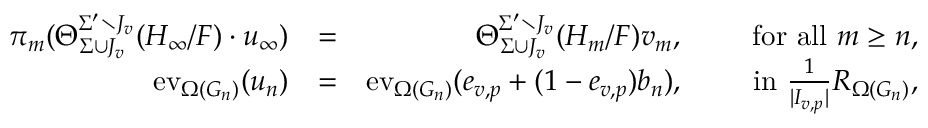<formula> <loc_0><loc_0><loc_500><loc_500>\begin{array} { r l r } { \pi _ { m } ( \Theta _ { \Sigma \cup J _ { v } } ^ { \Sigma ^ { \prime } \ J _ { v } } ( H _ { \infty } / F ) \cdot u _ { \infty } ) } & { = } & { \Theta _ { \Sigma \cup J _ { v } } ^ { \Sigma ^ { \prime } \ J _ { v } } ( H _ { m } / F ) v _ { m } , \quad f o r a l l m \geq n , } \\ { e v _ { \Omega ( G _ { n } ) } ( u _ { n } ) } & { = } & { e v _ { \Omega ( G _ { n } ) } ( e _ { v , p } + ( 1 - e _ { v , p } ) b _ { n } ) , \quad i n \frac { 1 } { | I _ { v , p } | } R _ { \Omega ( G _ { n } ) } , } \end{array}</formula> 